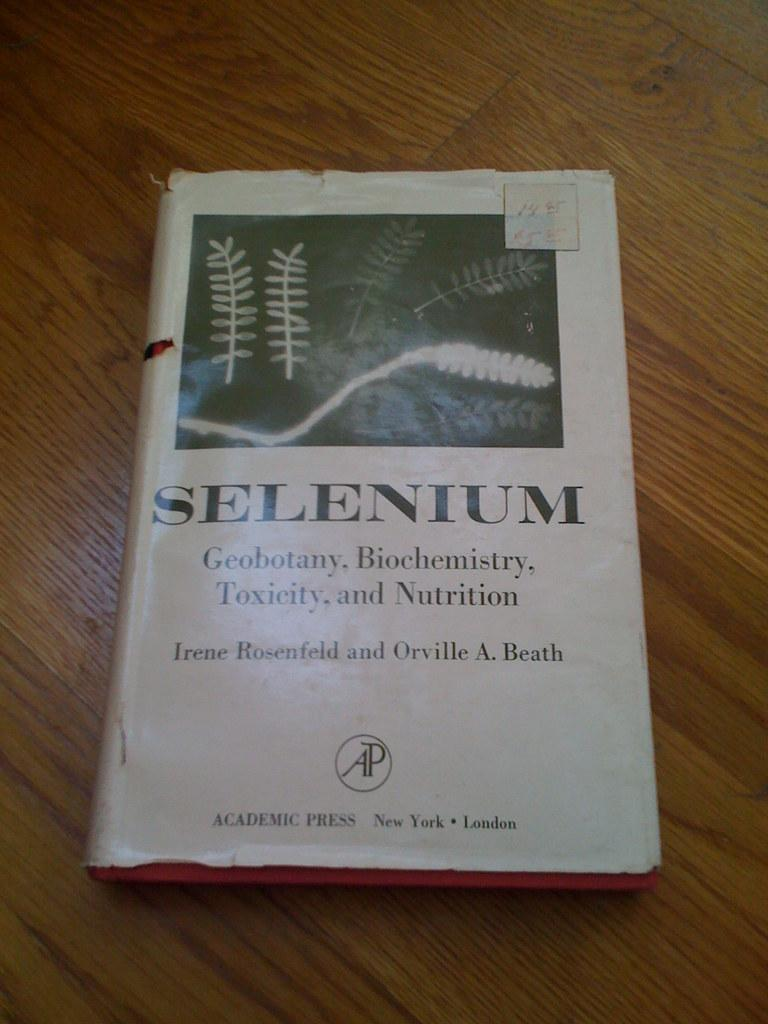<image>
Relay a brief, clear account of the picture shown. A book titled Selenium Geobotany, Biochemistry, Toxicity and Nutrition. 